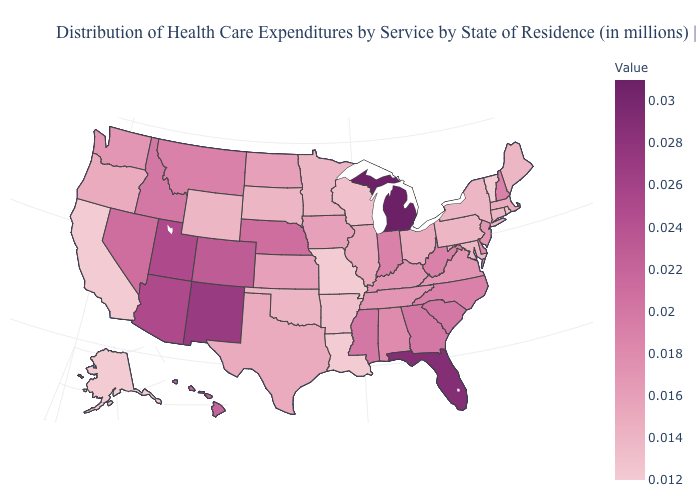Does Iowa have the highest value in the MidWest?
Give a very brief answer. No. Does the map have missing data?
Answer briefly. No. Among the states that border Indiana , which have the highest value?
Concise answer only. Michigan. Among the states that border Florida , does Alabama have the lowest value?
Give a very brief answer. Yes. Which states have the lowest value in the Northeast?
Write a very short answer. Vermont. 